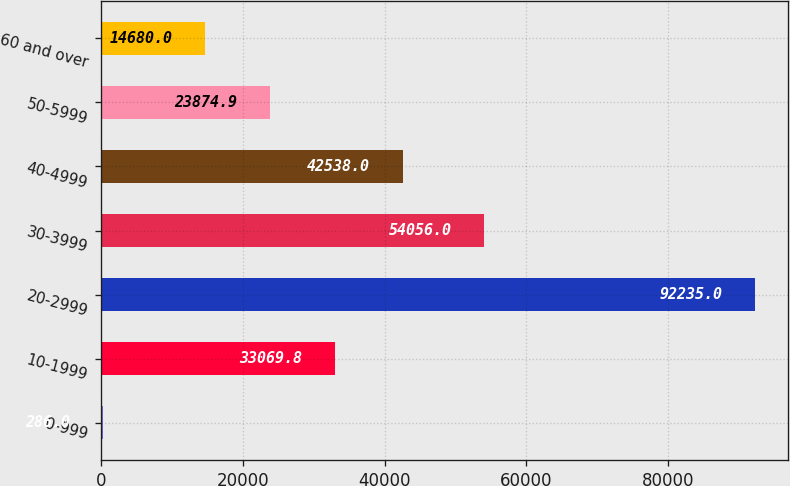Convert chart. <chart><loc_0><loc_0><loc_500><loc_500><bar_chart><fcel>0-999<fcel>10-1999<fcel>20-2999<fcel>30-3999<fcel>40-4999<fcel>50-5999<fcel>60 and over<nl><fcel>286<fcel>33069.8<fcel>92235<fcel>54056<fcel>42538<fcel>23874.9<fcel>14680<nl></chart> 